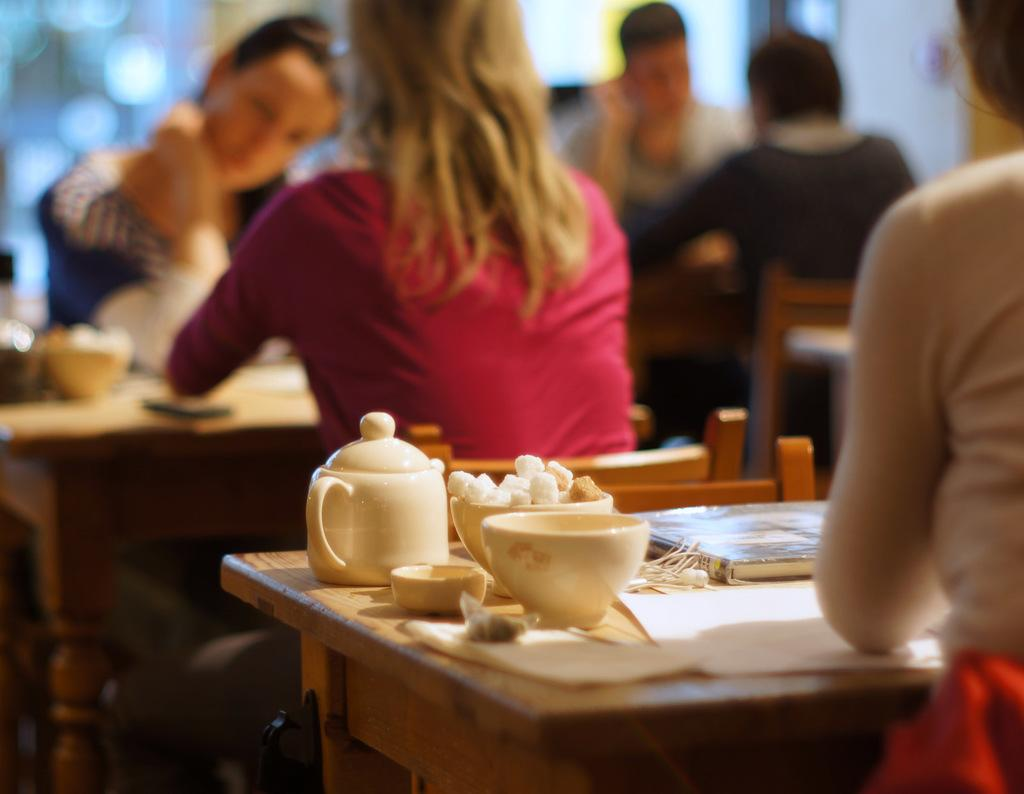What are the people in the image doing? The persons in the image are sitting on chairs. What is on the table in the image? There are bowls, a kettle, a book, a headset, and paper on the table. How many chairs are visible in the image? There are chairs in the image. What is the purpose of the headset on the table? The purpose of the headset on the table is not specified in the image, but it is commonly used for audio communication or entertainment. Can you see a crow using a wing to stir the contents of the kettle in the image? There is no crow or wing present in the image, and the kettle is not being stirred. 